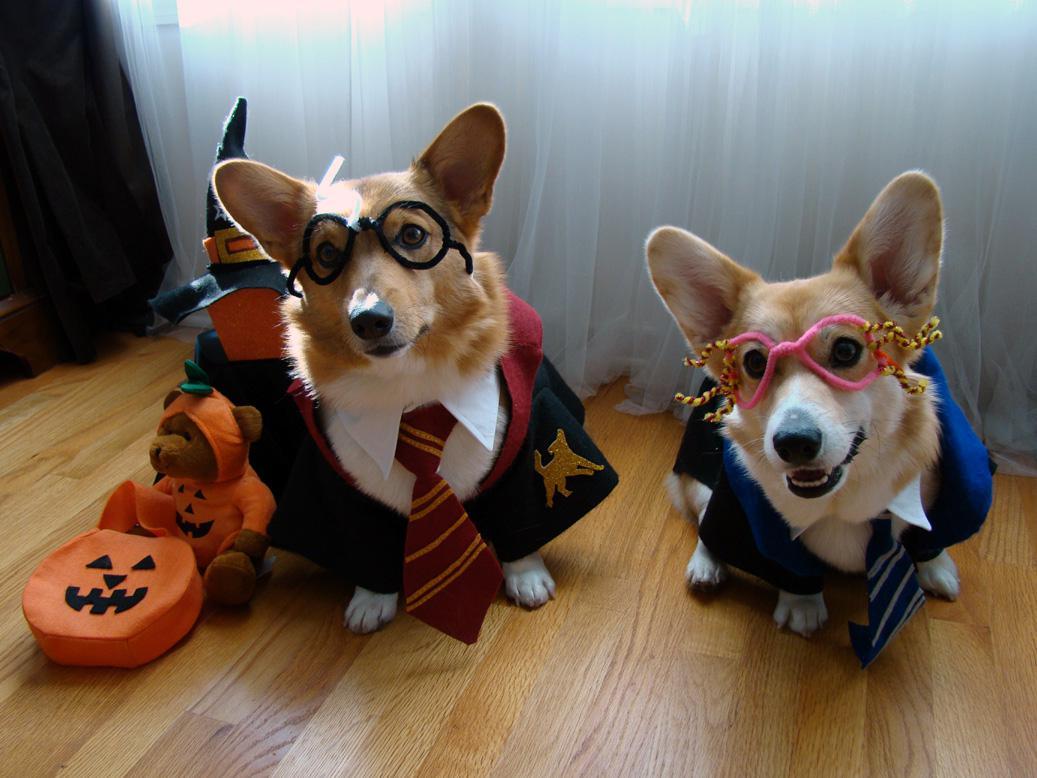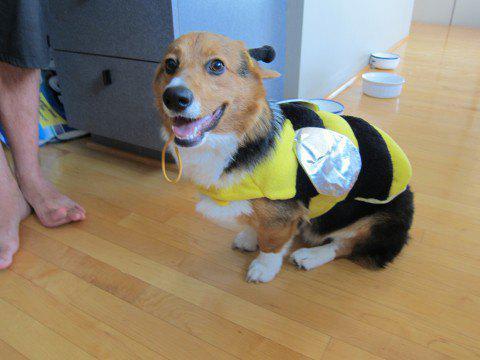The first image is the image on the left, the second image is the image on the right. Analyze the images presented: Is the assertion "There is two dogs in the right image." valid? Answer yes or no. No. The first image is the image on the left, the second image is the image on the right. Examine the images to the left and right. Is the description "All dogs are wearing costumes, and at least three dogs are wearing black-and-yellow bee costumes." accurate? Answer yes or no. No. 